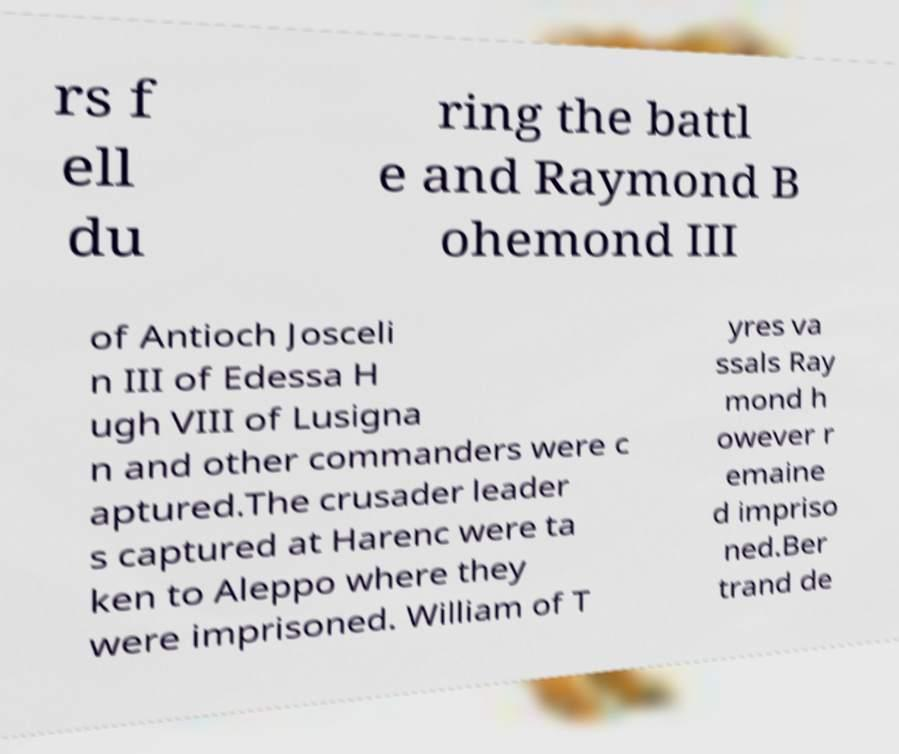What messages or text are displayed in this image? I need them in a readable, typed format. rs f ell du ring the battl e and Raymond B ohemond III of Antioch Josceli n III of Edessa H ugh VIII of Lusigna n and other commanders were c aptured.The crusader leader s captured at Harenc were ta ken to Aleppo where they were imprisoned. William of T yres va ssals Ray mond h owever r emaine d impriso ned.Ber trand de 